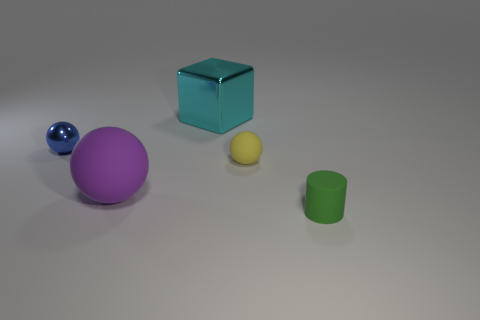Add 2 tiny things. How many objects exist? 7 Subtract all big spheres. How many spheres are left? 2 Subtract all balls. How many objects are left? 2 Add 3 large matte spheres. How many large matte spheres exist? 4 Subtract 0 red balls. How many objects are left? 5 Subtract all matte spheres. Subtract all cubes. How many objects are left? 2 Add 2 tiny blue things. How many tiny blue things are left? 3 